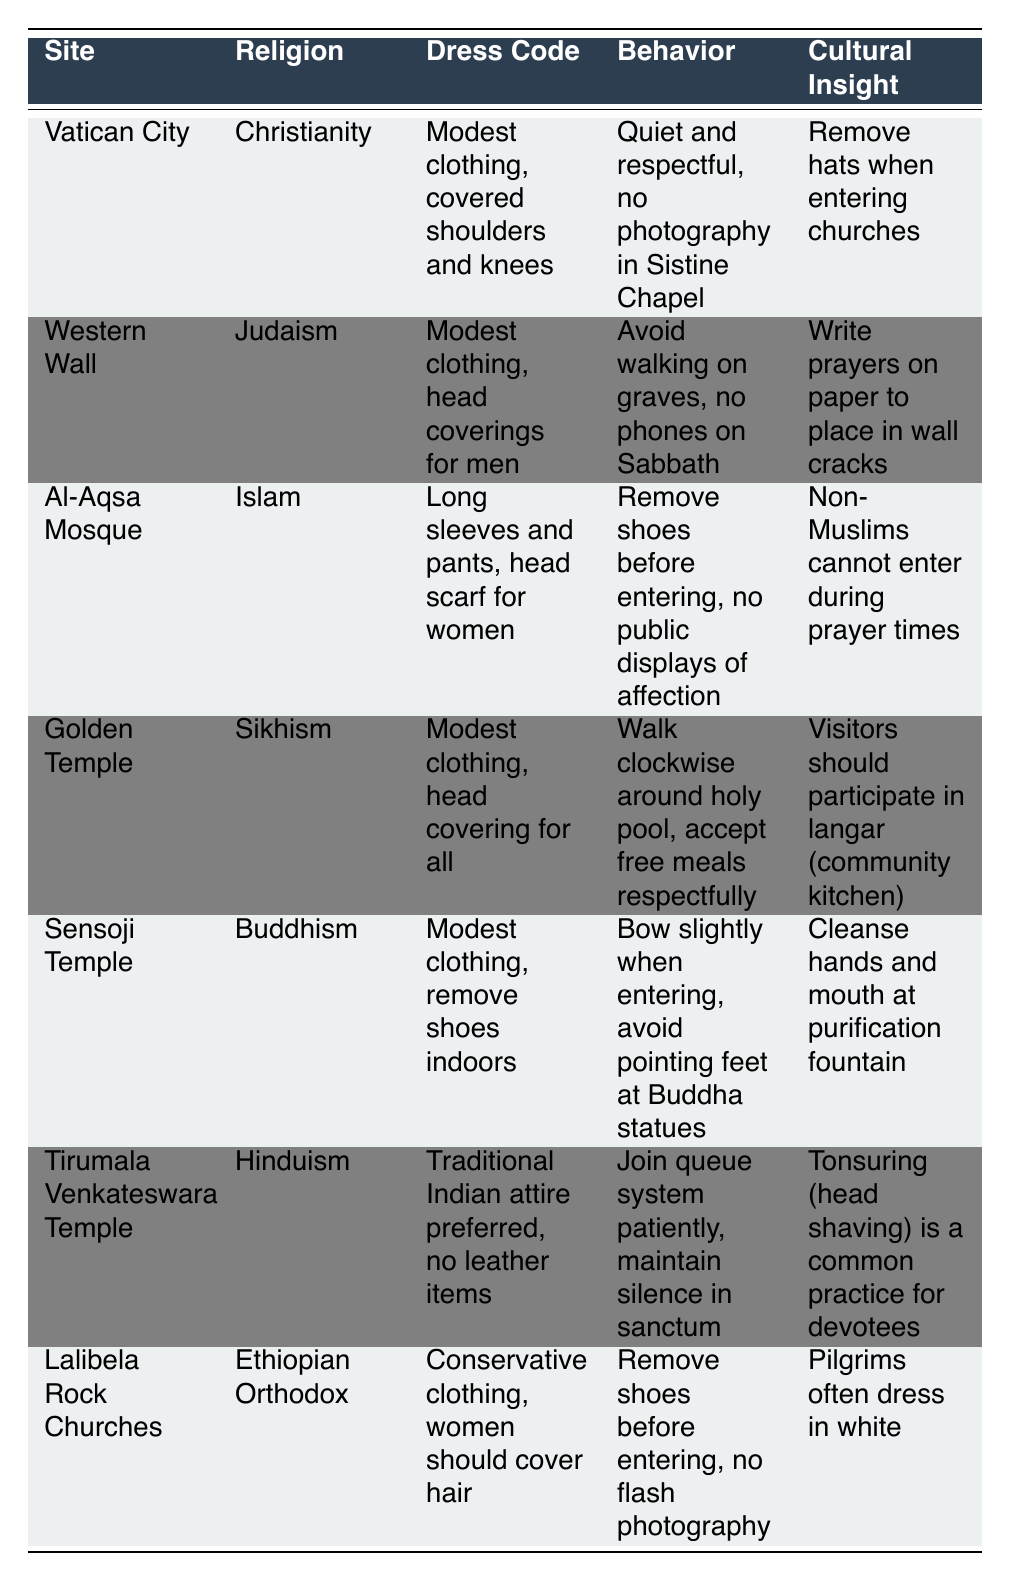What is the dress code for visiting the Al-Aqsa Mosque? The table specifies that the dress code for the Al-Aqsa Mosque includes long sleeves and pants, and a head scarf is required for women.
Answer: Long sleeves and pants, head scarf for women What behavior is expected when visiting the Golden Temple? According to the table, visitors to the Golden Temple should walk clockwise around the holy pool and accept free meals respectfully.
Answer: Walk clockwise around holy pool, accept free meals respectfully Is photography allowed in the Sistine Chapel? The table indicates that photography is not allowed in the Sistine Chapel.
Answer: No Which religious site requires head coverings for men? The table notes that the Western Wall has a dress code that includes head coverings for men.
Answer: Western Wall What is a cultural insight for visitors to the Lalibela Rock Churches? The table highlights that a cultural insight for the Lalibela Rock Churches is that pilgrims often dress in white.
Answer: Pilgrims often dress in white Which religious site has a queue system that visitors should join patiently? The table shows that the Tirumala Venkateswara Temple has a queue system that requires visitors to join patiently.
Answer: Tirumala Venkateswara Temple What dress code is preferred at the Tirumala Venkateswara Temple? The table specifies that traditional Indian attire is preferred at the Tirumala Venkateswara Temple, and no leather items are allowed.
Answer: Traditional Indian attire preferred, no leather items Are shoes to be removed before entering the Sensoji Temple? Yes, the table states that visitors should remove shoes indoors at the Sensoji Temple.
Answer: Yes Which two religious sites require removing shoes before entering? The table indicates that both the Al-Aqsa Mosque and Lalibela Rock Churches require visitors to remove shoes before entering.
Answer: Al-Aqsa Mosque and Lalibela Rock Churches If a visitor wants to avoid pointing feet at Buddha statues, which site should they be mindful at? The table mentions that visitors should avoid pointing feet at Buddha statues when at the Sensoji Temple.
Answer: Sensoji Temple What cultural insight is provided about the Golden Temple? The table states that visitors should participate in langar, which is a community kitchen, at the Golden Temple.
Answer: Visitors should participate in langar How do the dress codes of Vatican City and Lalibela Rock Churches compare in terms of conservativeness? Both sites require conservative dress, with Vatican City specifying modest clothing with covered shoulders and knees, while Lalibela emphasizes conservative clothing with women covering their hair. This indicates both sites prioritize modesty.
Answer: Dress codes are both conservative What is a common practice for devotees at the Tirumala Venkateswara Temple? The table explains that tonsuring, or head shaving, is a common practice for devotees at the Tirumala Venkateswara Temple.
Answer: Tonsuring (head shaving) is common practice What should visitors to the Western Wall avoid doing on the Sabbath? Visitors are advised to avoid using phones on the Sabbath when visiting the Western Wall according to the table.
Answer: Avoid phones on Sabbath What are the expected behaviors at Al-Aqsa Mosque regarding public displays of affection? The table indicates that public displays of affection are not allowed at the Al-Aqsa Mosque.
Answer: No public displays of affection allowed 